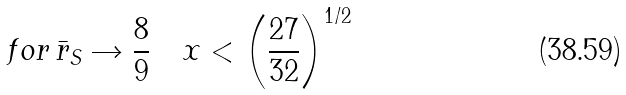Convert formula to latex. <formula><loc_0><loc_0><loc_500><loc_500>f o r \, \bar { r } _ { S } \rightarrow \frac { 8 } { 9 } \quad x < \left ( \frac { 2 7 } { 3 2 } \right ) ^ { 1 / 2 }</formula> 